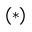<formula> <loc_0><loc_0><loc_500><loc_500>^ { ( * ) }</formula> 